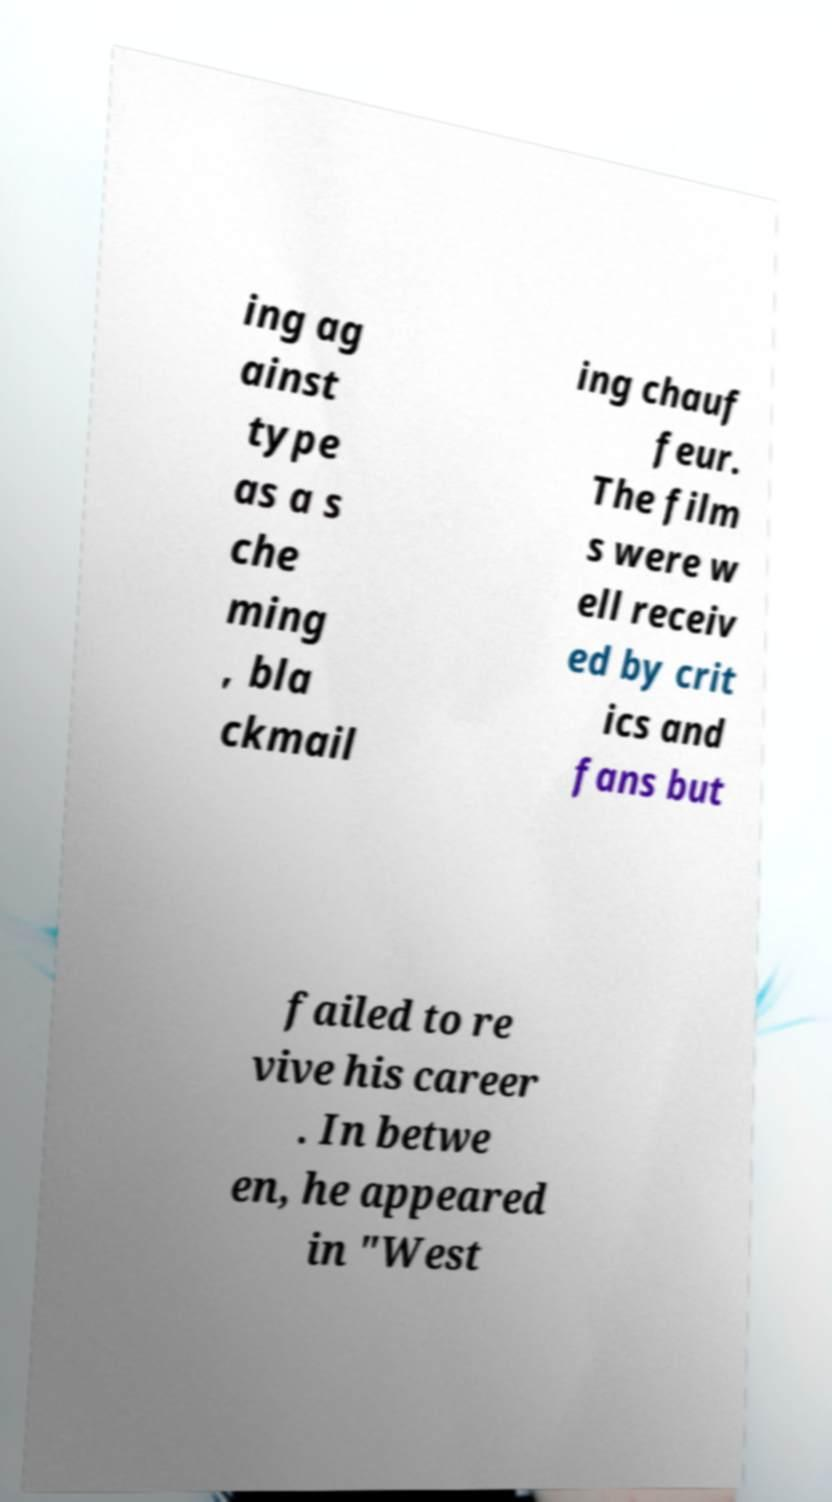Can you accurately transcribe the text from the provided image for me? ing ag ainst type as a s che ming , bla ckmail ing chauf feur. The film s were w ell receiv ed by crit ics and fans but failed to re vive his career . In betwe en, he appeared in "West 